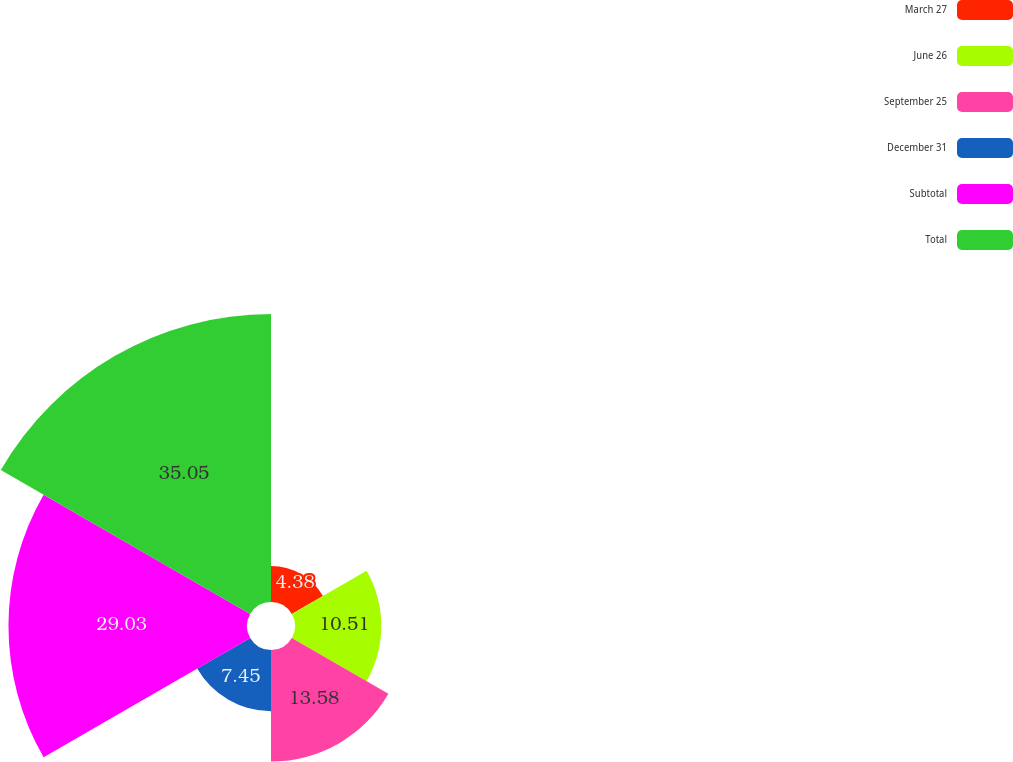<chart> <loc_0><loc_0><loc_500><loc_500><pie_chart><fcel>March 27<fcel>June 26<fcel>September 25<fcel>December 31<fcel>Subtotal<fcel>Total<nl><fcel>4.38%<fcel>10.51%<fcel>13.58%<fcel>7.45%<fcel>29.03%<fcel>35.05%<nl></chart> 